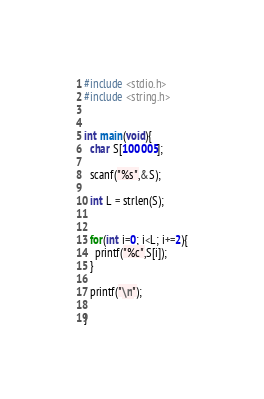<code> <loc_0><loc_0><loc_500><loc_500><_C_>#include <stdio.h>
#include <string.h>


int main(void){
  char S[100005];

  scanf("%s",&S);

  int L = strlen(S);


  for(int i=0; i<L; i+=2){
    printf("%c",S[i]);
  }

  printf("\n");

}
</code> 